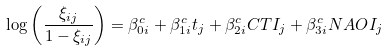Convert formula to latex. <formula><loc_0><loc_0><loc_500><loc_500>\log \left ( \frac { \xi _ { i j } } { 1 - \xi _ { i j } } \right ) = \beta _ { 0 i } ^ { c } + \beta _ { 1 i } ^ { c } t _ { j } + \beta _ { 2 i } ^ { c } C T I _ { j } + \beta _ { 3 i } ^ { c } N A O I _ { j }</formula> 